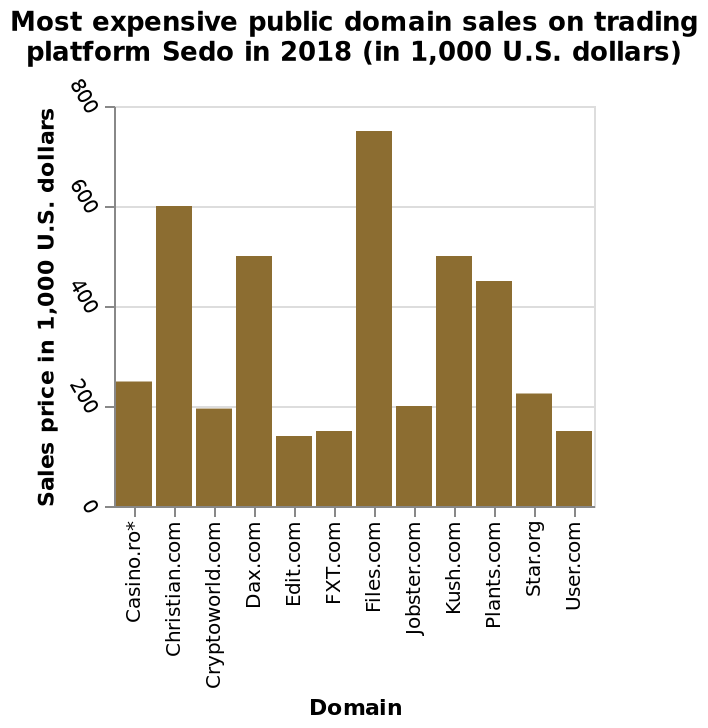<image>
What was the second most expensive public domain sale on Sedo in 2018? Christian.com. What is the highest sales price for a public domain on the trading platform Sedo in 2018?  The highest sales price for a public domain on the trading platform Sedo in 2018 is 800,000 U.S. dollars. How does the price of the most expensive public domain compare to Christian.com?  Files.com was almost 1.25 times more expensive than Christian.com. Describe the following image in detail Most expensive public domain sales on trading platform Sedo in 2018 (in 1,000 U.S. dollars) is a bar diagram. Domain is drawn as a categorical scale starting with Casino.ro* and ending with User.com on the x-axis. There is a linear scale of range 0 to 800 along the y-axis, marked Sales price in 1,000 U.S. dollars. 